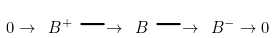Convert formula to latex. <formula><loc_0><loc_0><loc_500><loc_500>0 \rightarrow \ B ^ { + } \longrightarrow \ B \longrightarrow \ B ^ { - } \rightarrow 0</formula> 